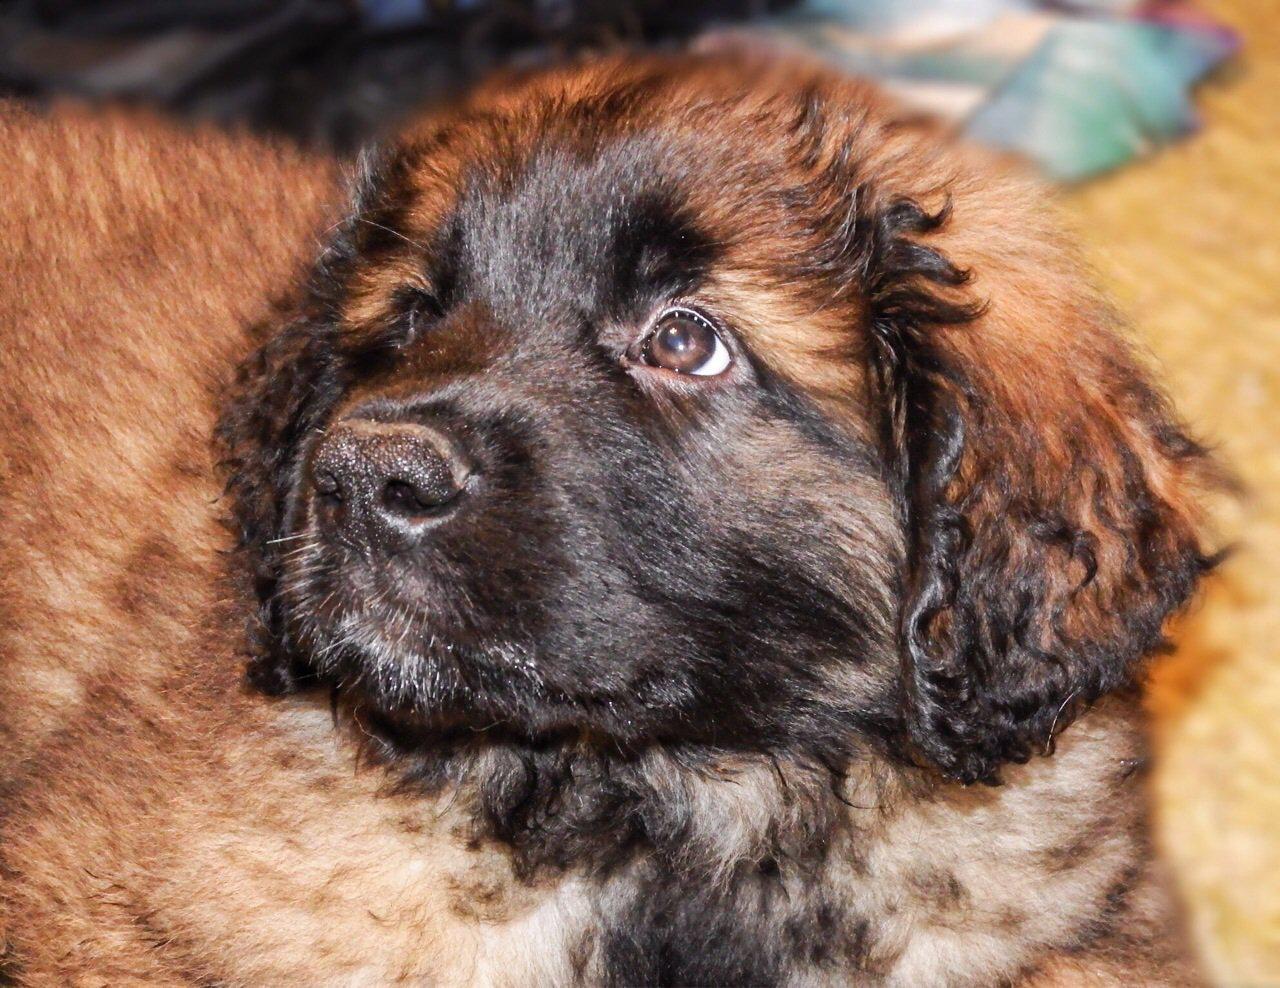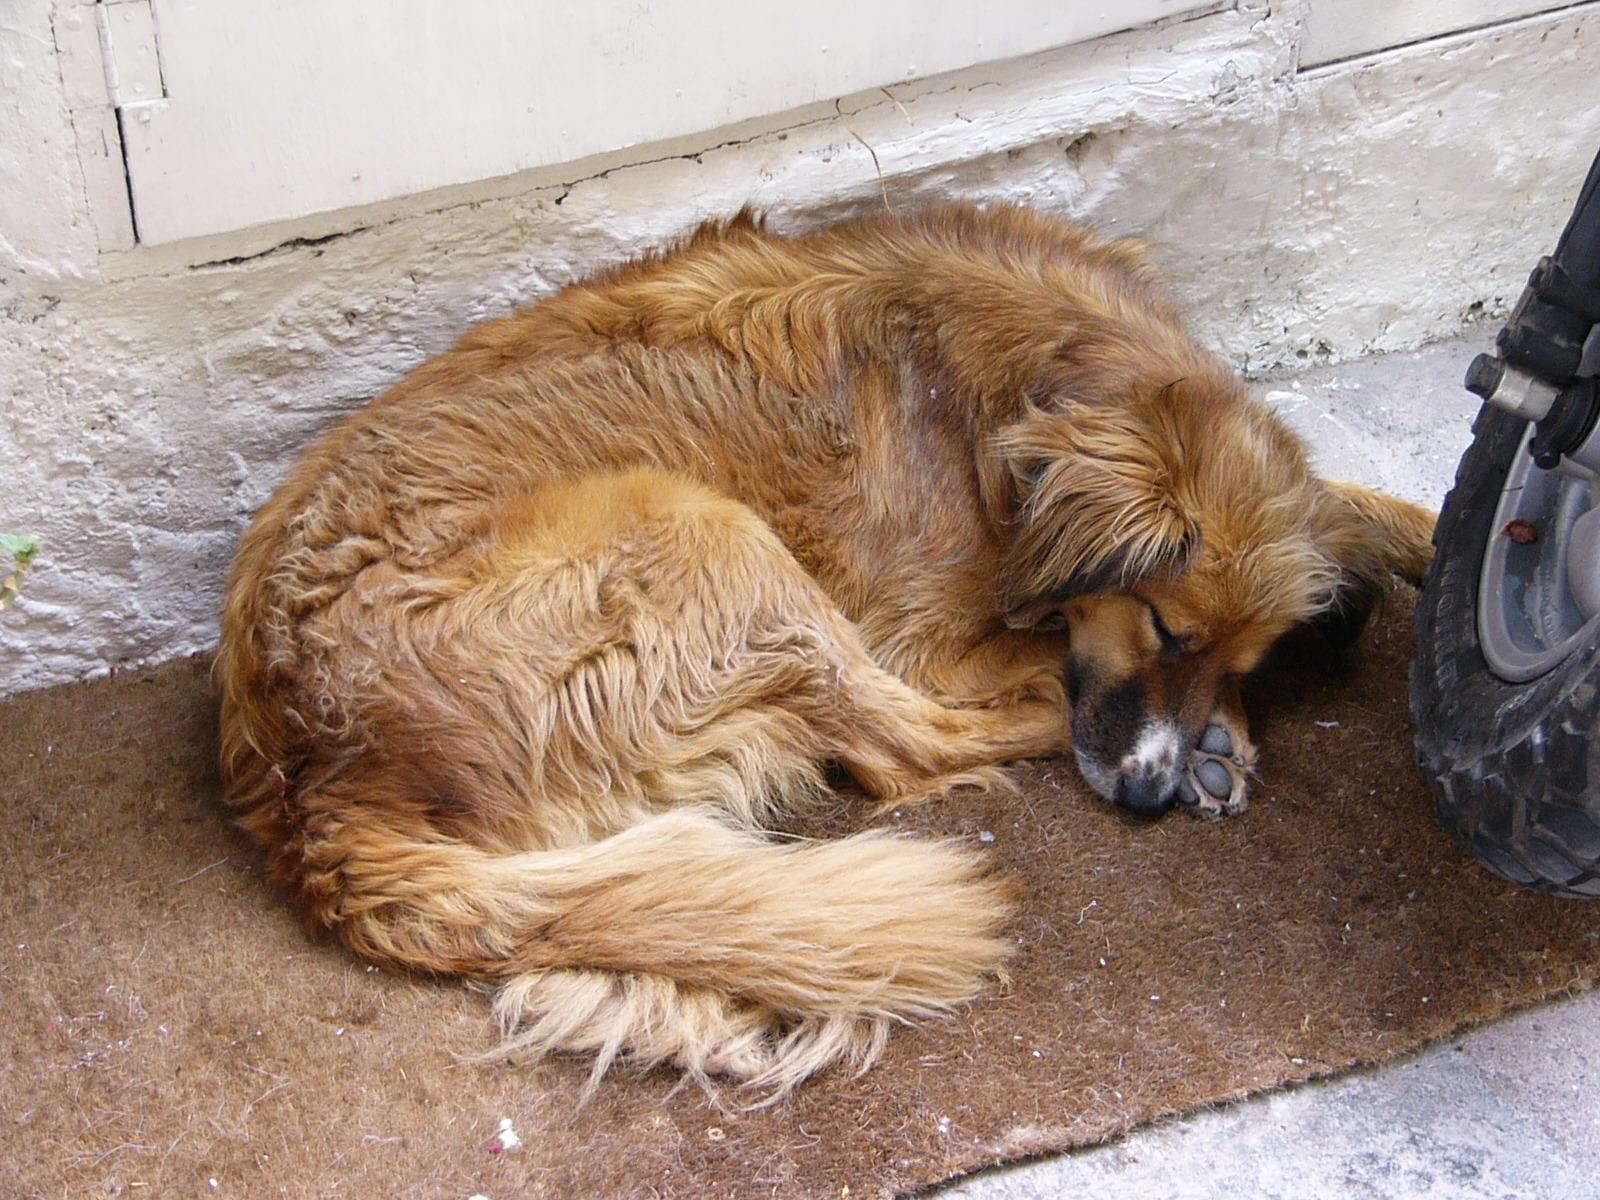The first image is the image on the left, the second image is the image on the right. Given the left and right images, does the statement "There is a single brown dog sleeping alone in the image on the right." hold true? Answer yes or no. Yes. The first image is the image on the left, the second image is the image on the right. Given the left and right images, does the statement "A dog's pink tongue is visible in one image." hold true? Answer yes or no. No. 